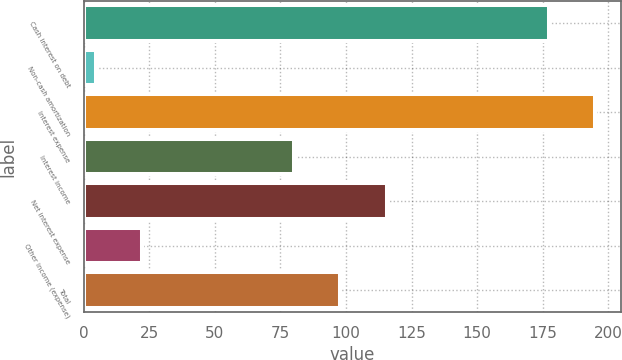<chart> <loc_0><loc_0><loc_500><loc_500><bar_chart><fcel>Cash interest on debt<fcel>Non-cash amortization<fcel>Interest expense<fcel>Interest income<fcel>Net interest expense<fcel>Other income (expense)<fcel>Total<nl><fcel>177.3<fcel>4.6<fcel>195.03<fcel>80<fcel>115.46<fcel>22.33<fcel>97.73<nl></chart> 